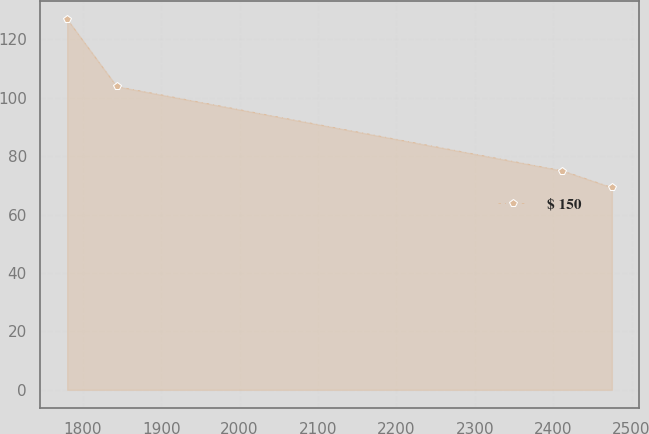Convert chart to OTSL. <chart><loc_0><loc_0><loc_500><loc_500><line_chart><ecel><fcel>$ 150<nl><fcel>1780.18<fcel>126.87<nl><fcel>1843.36<fcel>103.87<nl><fcel>2411.71<fcel>75.03<nl><fcel>2474.89<fcel>69.27<nl></chart> 